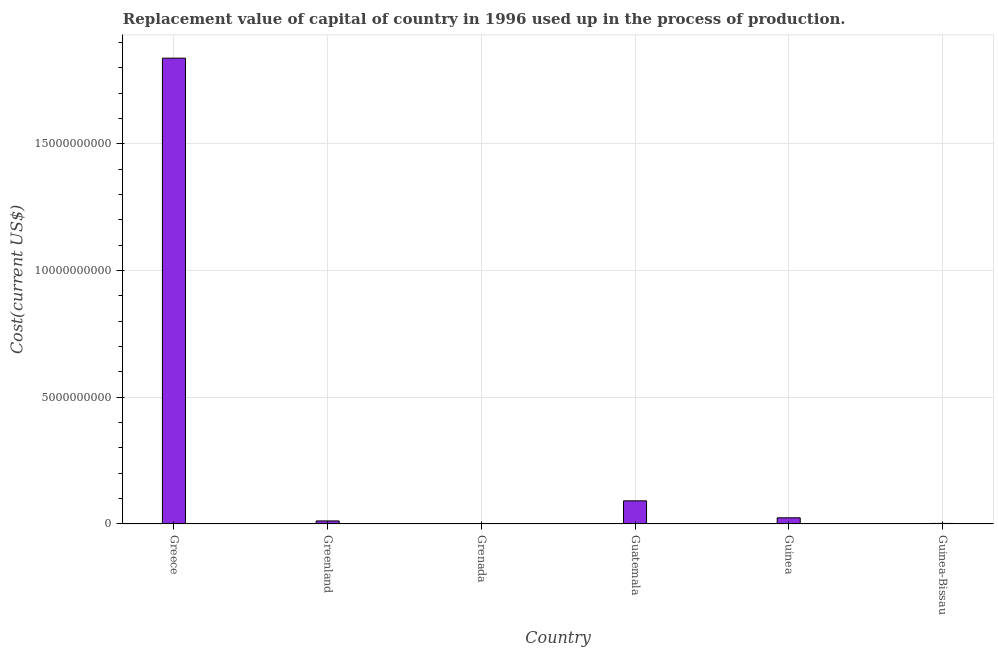Does the graph contain any zero values?
Offer a very short reply. No. Does the graph contain grids?
Ensure brevity in your answer.  Yes. What is the title of the graph?
Make the answer very short. Replacement value of capital of country in 1996 used up in the process of production. What is the label or title of the Y-axis?
Provide a succinct answer. Cost(current US$). What is the consumption of fixed capital in Greece?
Keep it short and to the point. 1.84e+1. Across all countries, what is the maximum consumption of fixed capital?
Ensure brevity in your answer.  1.84e+1. Across all countries, what is the minimum consumption of fixed capital?
Give a very brief answer. 1.65e+07. In which country was the consumption of fixed capital minimum?
Make the answer very short. Grenada. What is the sum of the consumption of fixed capital?
Offer a terse response. 1.97e+1. What is the difference between the consumption of fixed capital in Grenada and Guinea-Bissau?
Ensure brevity in your answer.  -4.96e+06. What is the average consumption of fixed capital per country?
Your response must be concise. 3.28e+09. What is the median consumption of fixed capital?
Provide a short and direct response. 1.82e+08. In how many countries, is the consumption of fixed capital greater than 7000000000 US$?
Offer a terse response. 1. What is the ratio of the consumption of fixed capital in Guatemala to that in Guinea-Bissau?
Your answer should be very brief. 42.53. Is the difference between the consumption of fixed capital in Greenland and Guinea greater than the difference between any two countries?
Offer a terse response. No. What is the difference between the highest and the second highest consumption of fixed capital?
Provide a succinct answer. 1.75e+1. What is the difference between the highest and the lowest consumption of fixed capital?
Offer a very short reply. 1.84e+1. In how many countries, is the consumption of fixed capital greater than the average consumption of fixed capital taken over all countries?
Ensure brevity in your answer.  1. How many bars are there?
Offer a terse response. 6. What is the difference between two consecutive major ticks on the Y-axis?
Offer a very short reply. 5.00e+09. Are the values on the major ticks of Y-axis written in scientific E-notation?
Keep it short and to the point. No. What is the Cost(current US$) of Greece?
Your response must be concise. 1.84e+1. What is the Cost(current US$) in Greenland?
Offer a very short reply. 1.21e+08. What is the Cost(current US$) in Grenada?
Provide a short and direct response. 1.65e+07. What is the Cost(current US$) of Guatemala?
Your answer should be compact. 9.13e+08. What is the Cost(current US$) of Guinea?
Provide a short and direct response. 2.44e+08. What is the Cost(current US$) in Guinea-Bissau?
Your answer should be very brief. 2.15e+07. What is the difference between the Cost(current US$) in Greece and Greenland?
Offer a very short reply. 1.83e+1. What is the difference between the Cost(current US$) in Greece and Grenada?
Your response must be concise. 1.84e+1. What is the difference between the Cost(current US$) in Greece and Guatemala?
Ensure brevity in your answer.  1.75e+1. What is the difference between the Cost(current US$) in Greece and Guinea?
Ensure brevity in your answer.  1.81e+1. What is the difference between the Cost(current US$) in Greece and Guinea-Bissau?
Keep it short and to the point. 1.84e+1. What is the difference between the Cost(current US$) in Greenland and Grenada?
Provide a succinct answer. 1.04e+08. What is the difference between the Cost(current US$) in Greenland and Guatemala?
Your response must be concise. -7.93e+08. What is the difference between the Cost(current US$) in Greenland and Guinea?
Provide a short and direct response. -1.23e+08. What is the difference between the Cost(current US$) in Greenland and Guinea-Bissau?
Offer a terse response. 9.92e+07. What is the difference between the Cost(current US$) in Grenada and Guatemala?
Your answer should be very brief. -8.97e+08. What is the difference between the Cost(current US$) in Grenada and Guinea?
Ensure brevity in your answer.  -2.27e+08. What is the difference between the Cost(current US$) in Grenada and Guinea-Bissau?
Provide a succinct answer. -4.96e+06. What is the difference between the Cost(current US$) in Guatemala and Guinea?
Ensure brevity in your answer.  6.70e+08. What is the difference between the Cost(current US$) in Guatemala and Guinea-Bissau?
Your answer should be compact. 8.92e+08. What is the difference between the Cost(current US$) in Guinea and Guinea-Bissau?
Your answer should be very brief. 2.22e+08. What is the ratio of the Cost(current US$) in Greece to that in Greenland?
Make the answer very short. 152.41. What is the ratio of the Cost(current US$) in Greece to that in Grenada?
Provide a short and direct response. 1113.24. What is the ratio of the Cost(current US$) in Greece to that in Guatemala?
Make the answer very short. 20.13. What is the ratio of the Cost(current US$) in Greece to that in Guinea?
Provide a succinct answer. 75.49. What is the ratio of the Cost(current US$) in Greece to that in Guinea-Bissau?
Make the answer very short. 856.02. What is the ratio of the Cost(current US$) in Greenland to that in Grenada?
Your response must be concise. 7.3. What is the ratio of the Cost(current US$) in Greenland to that in Guatemala?
Your response must be concise. 0.13. What is the ratio of the Cost(current US$) in Greenland to that in Guinea?
Your response must be concise. 0.49. What is the ratio of the Cost(current US$) in Greenland to that in Guinea-Bissau?
Your answer should be very brief. 5.62. What is the ratio of the Cost(current US$) in Grenada to that in Guatemala?
Provide a succinct answer. 0.02. What is the ratio of the Cost(current US$) in Grenada to that in Guinea?
Give a very brief answer. 0.07. What is the ratio of the Cost(current US$) in Grenada to that in Guinea-Bissau?
Your response must be concise. 0.77. What is the ratio of the Cost(current US$) in Guatemala to that in Guinea?
Your response must be concise. 3.75. What is the ratio of the Cost(current US$) in Guatemala to that in Guinea-Bissau?
Offer a very short reply. 42.53. What is the ratio of the Cost(current US$) in Guinea to that in Guinea-Bissau?
Give a very brief answer. 11.34. 